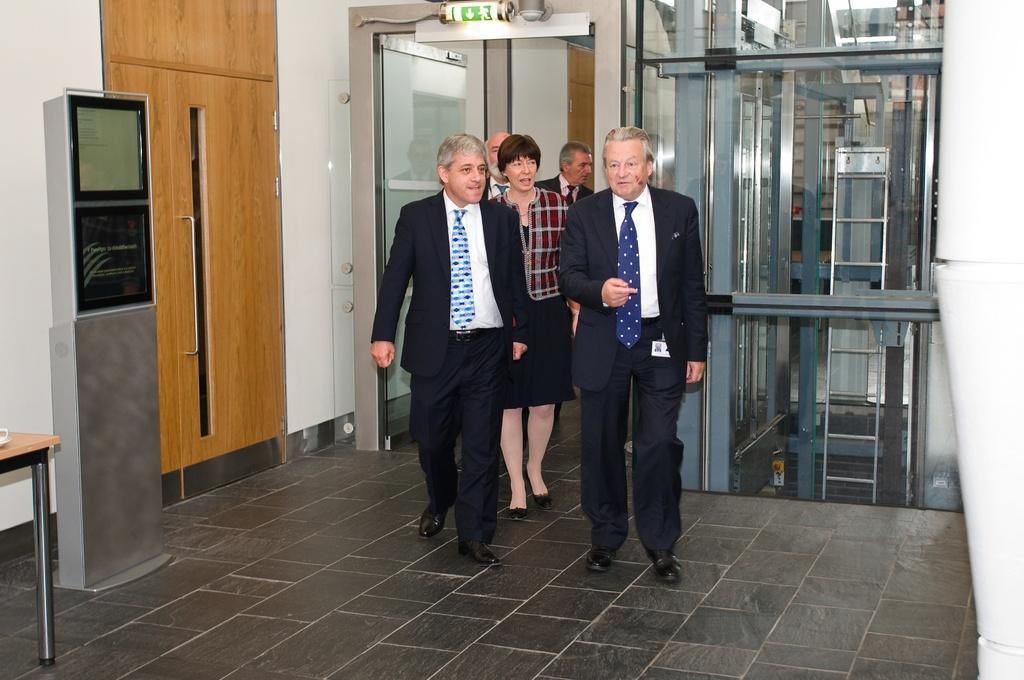Could you give a brief overview of what you see in this image? In the image there are a group of people entering into a room, there is some machine on the left side, beside the machine there is a door and in the background there is a wall. There are glass windows behind the people on the right side. 